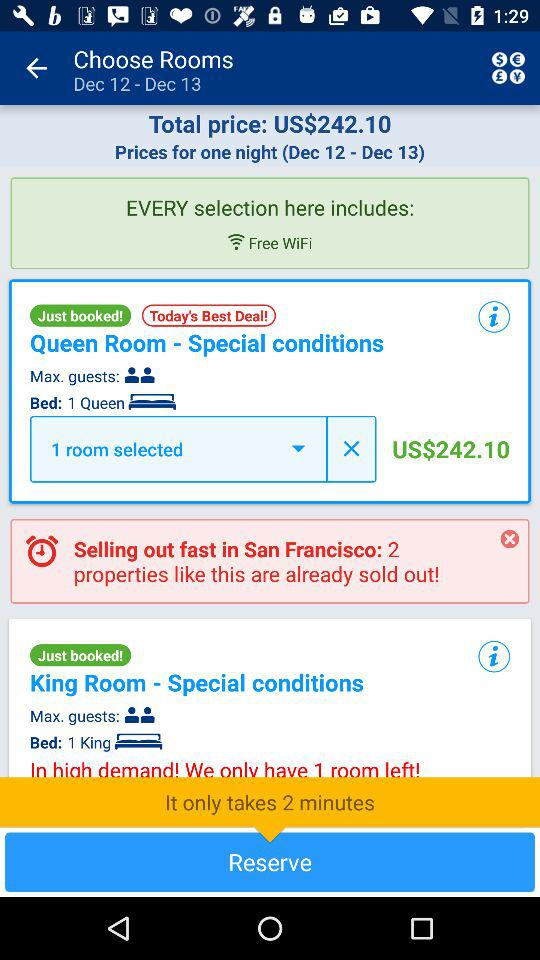Is WiFi free?
Answer the question using a single word or phrase. WiFi is free. 